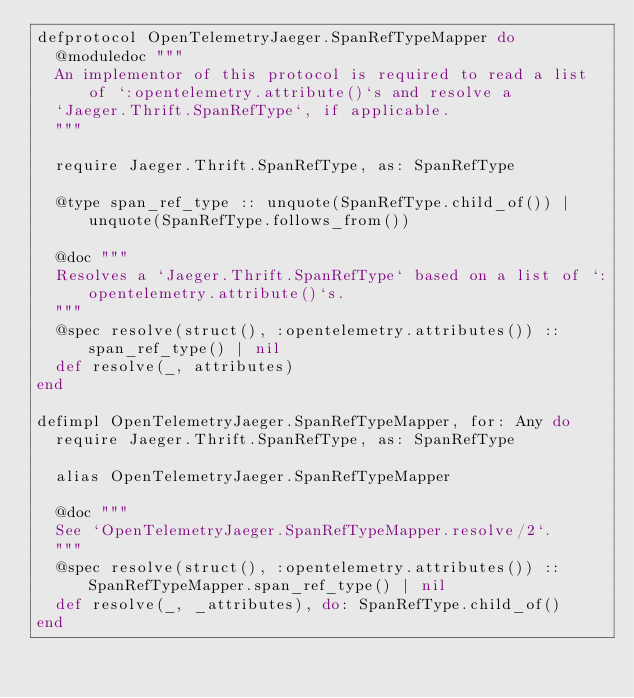<code> <loc_0><loc_0><loc_500><loc_500><_Elixir_>defprotocol OpenTelemetryJaeger.SpanRefTypeMapper do
  @moduledoc """
  An implementor of this protocol is required to read a list of `:opentelemetry.attribute()`s and resolve a
  `Jaeger.Thrift.SpanRefType`, if applicable.
  """

  require Jaeger.Thrift.SpanRefType, as: SpanRefType

  @type span_ref_type :: unquote(SpanRefType.child_of()) | unquote(SpanRefType.follows_from())

  @doc """
  Resolves a `Jaeger.Thrift.SpanRefType` based on a list of `:opentelemetry.attribute()`s.
  """
  @spec resolve(struct(), :opentelemetry.attributes()) :: span_ref_type() | nil
  def resolve(_, attributes)
end

defimpl OpenTelemetryJaeger.SpanRefTypeMapper, for: Any do
  require Jaeger.Thrift.SpanRefType, as: SpanRefType

  alias OpenTelemetryJaeger.SpanRefTypeMapper

  @doc """
  See `OpenTelemetryJaeger.SpanRefTypeMapper.resolve/2`.
  """
  @spec resolve(struct(), :opentelemetry.attributes()) :: SpanRefTypeMapper.span_ref_type() | nil
  def resolve(_, _attributes), do: SpanRefType.child_of()
end
</code> 